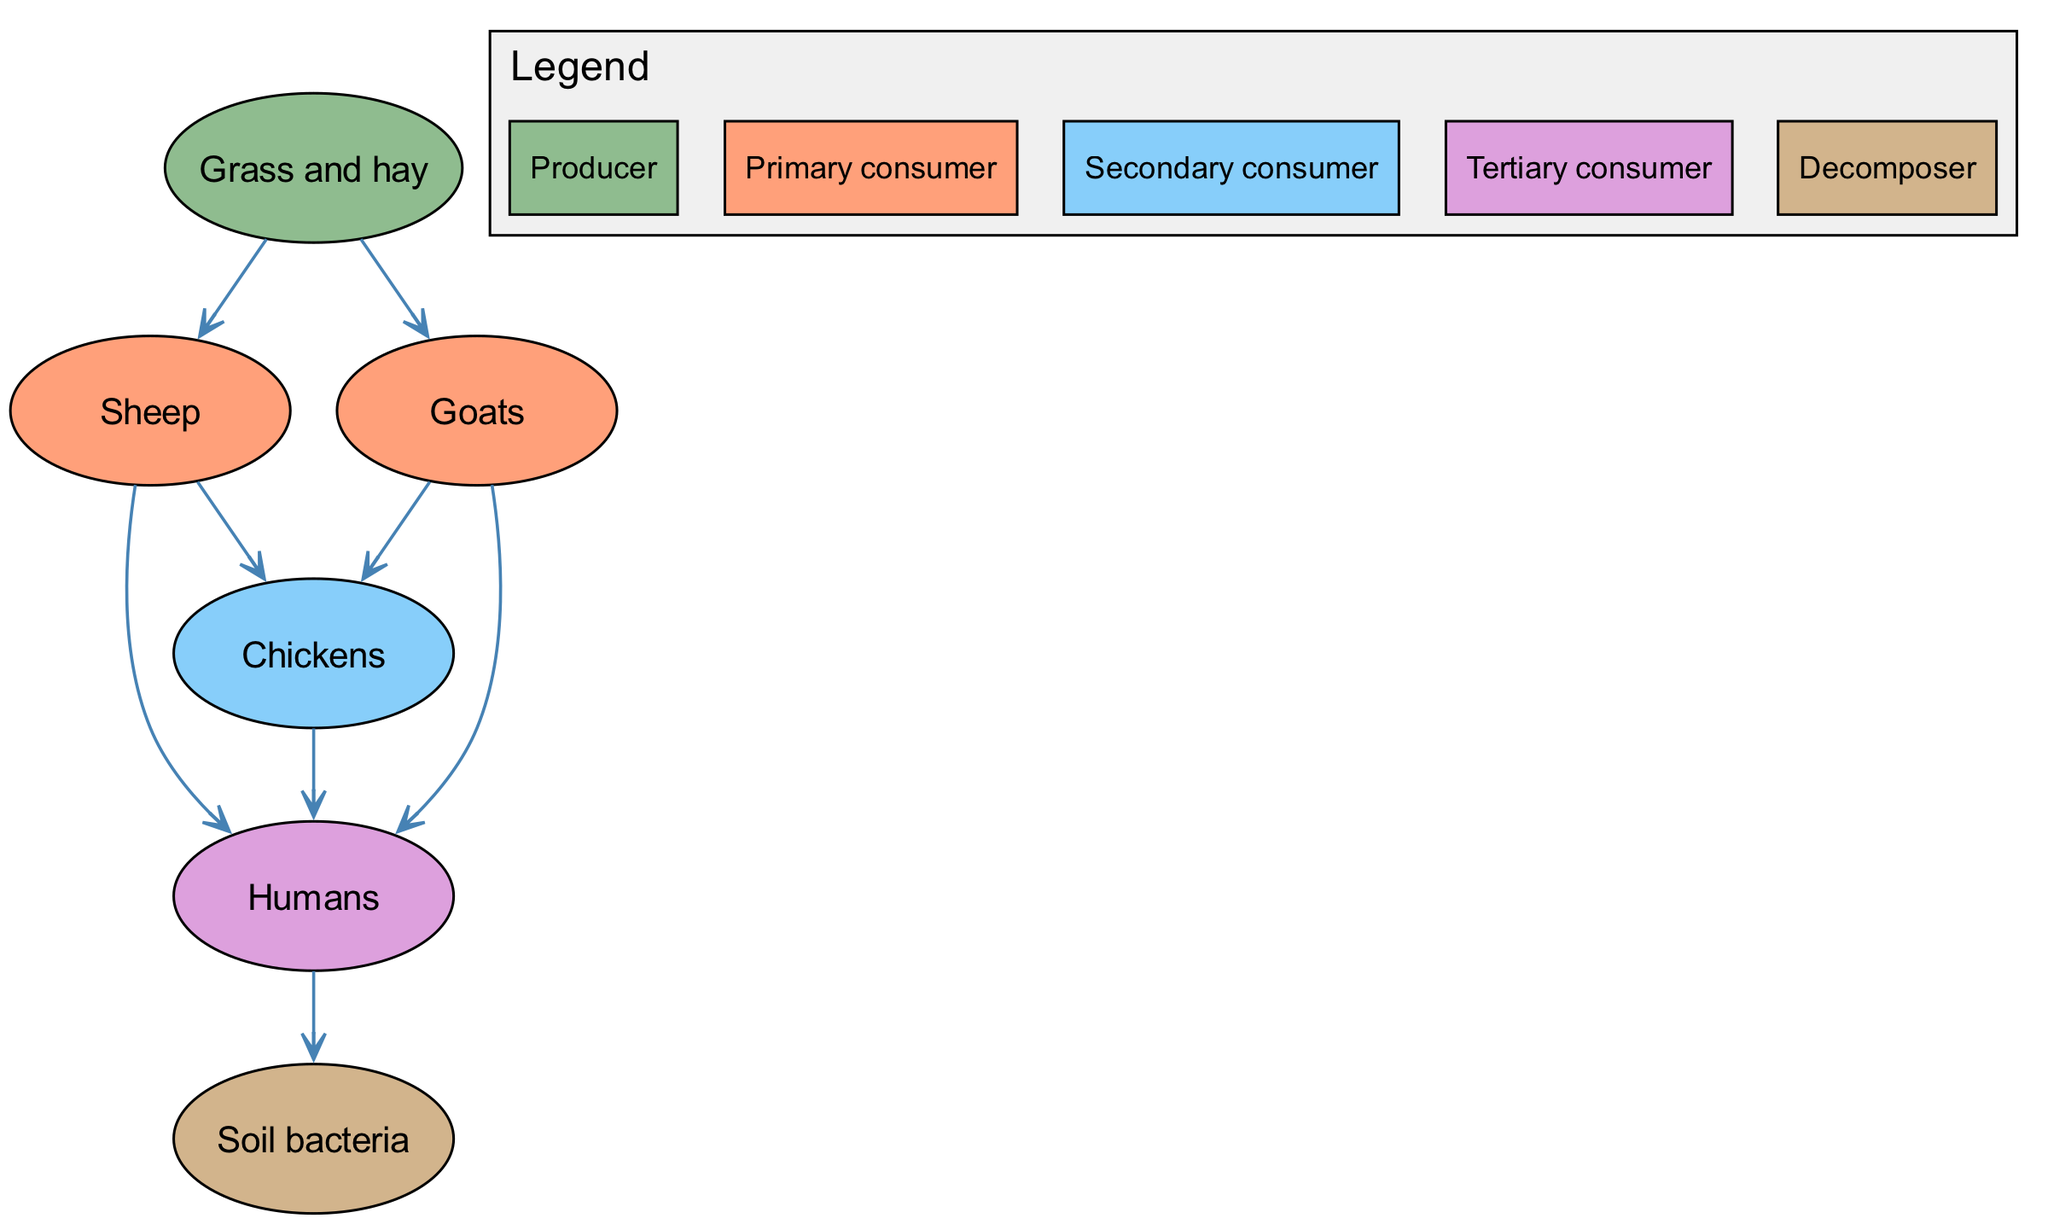What are the primary consumers in this food chain? The primary consumers in the food chain are listed as nodes representing organisms that consume producers. According to the diagram, the primary consumers are Sheep and Goats.
Answer: Sheep, Goats How many total nodes are in the diagram? The total number of nodes can be determined by counting each unique element in the diagram. There are six unique elements: Grass and hay, Sheep, Goats, Chickens, Humans, and Soil bacteria.
Answer: 6 Which consumers are linked directly to Humans in the food chain? To find the consumers linked directly to Humans, we examine the outgoing edges from the Humans node. According to the diagram, the consumers that link directly to Humans are Chickens, Sheep, and Goats.
Answer: Chickens, Sheep, Goats What role do Soil bacteria play in this food chain? To determine the role of Soil bacteria, we look at the relationships in the diagram. Soil bacteria are listed as a decomposer, indicating that they break down organic matter, contributing to nutrient cycling in the ecosystem.
Answer: Decomposer How many relationships are there in this food chain? The number of relationships can be determined by counting each directed edge in the diagram connecting one element to another. There are eight relationships present.
Answer: 8 What is the ultimate source of food for Humans according to the food chain? To identify the ultimate source of food for Humans, we trace back the connections forward from Humans. The connections show that Humans feed on Chickens, Sheep, and Goats, making Grass and hay the ultimate source since it is consumed by those primary consumers.
Answer: Grass and hay Which organisms are considered secondary consumers in the food chain? Secondary consumers are organisms that eat primary consumers. In this diagram, Chickens are identified as the only secondary consumer, as they consume both Sheep and Goats.
Answer: Chickens Which type of consumer directly consumes Sheep? To find the type of consumer that directly consumes Sheep, we check the relationships stemming from the Sheep node. According to the diagram, Chickens consume Sheep, showing the direct interaction between these consumer types.
Answer: Chickens 